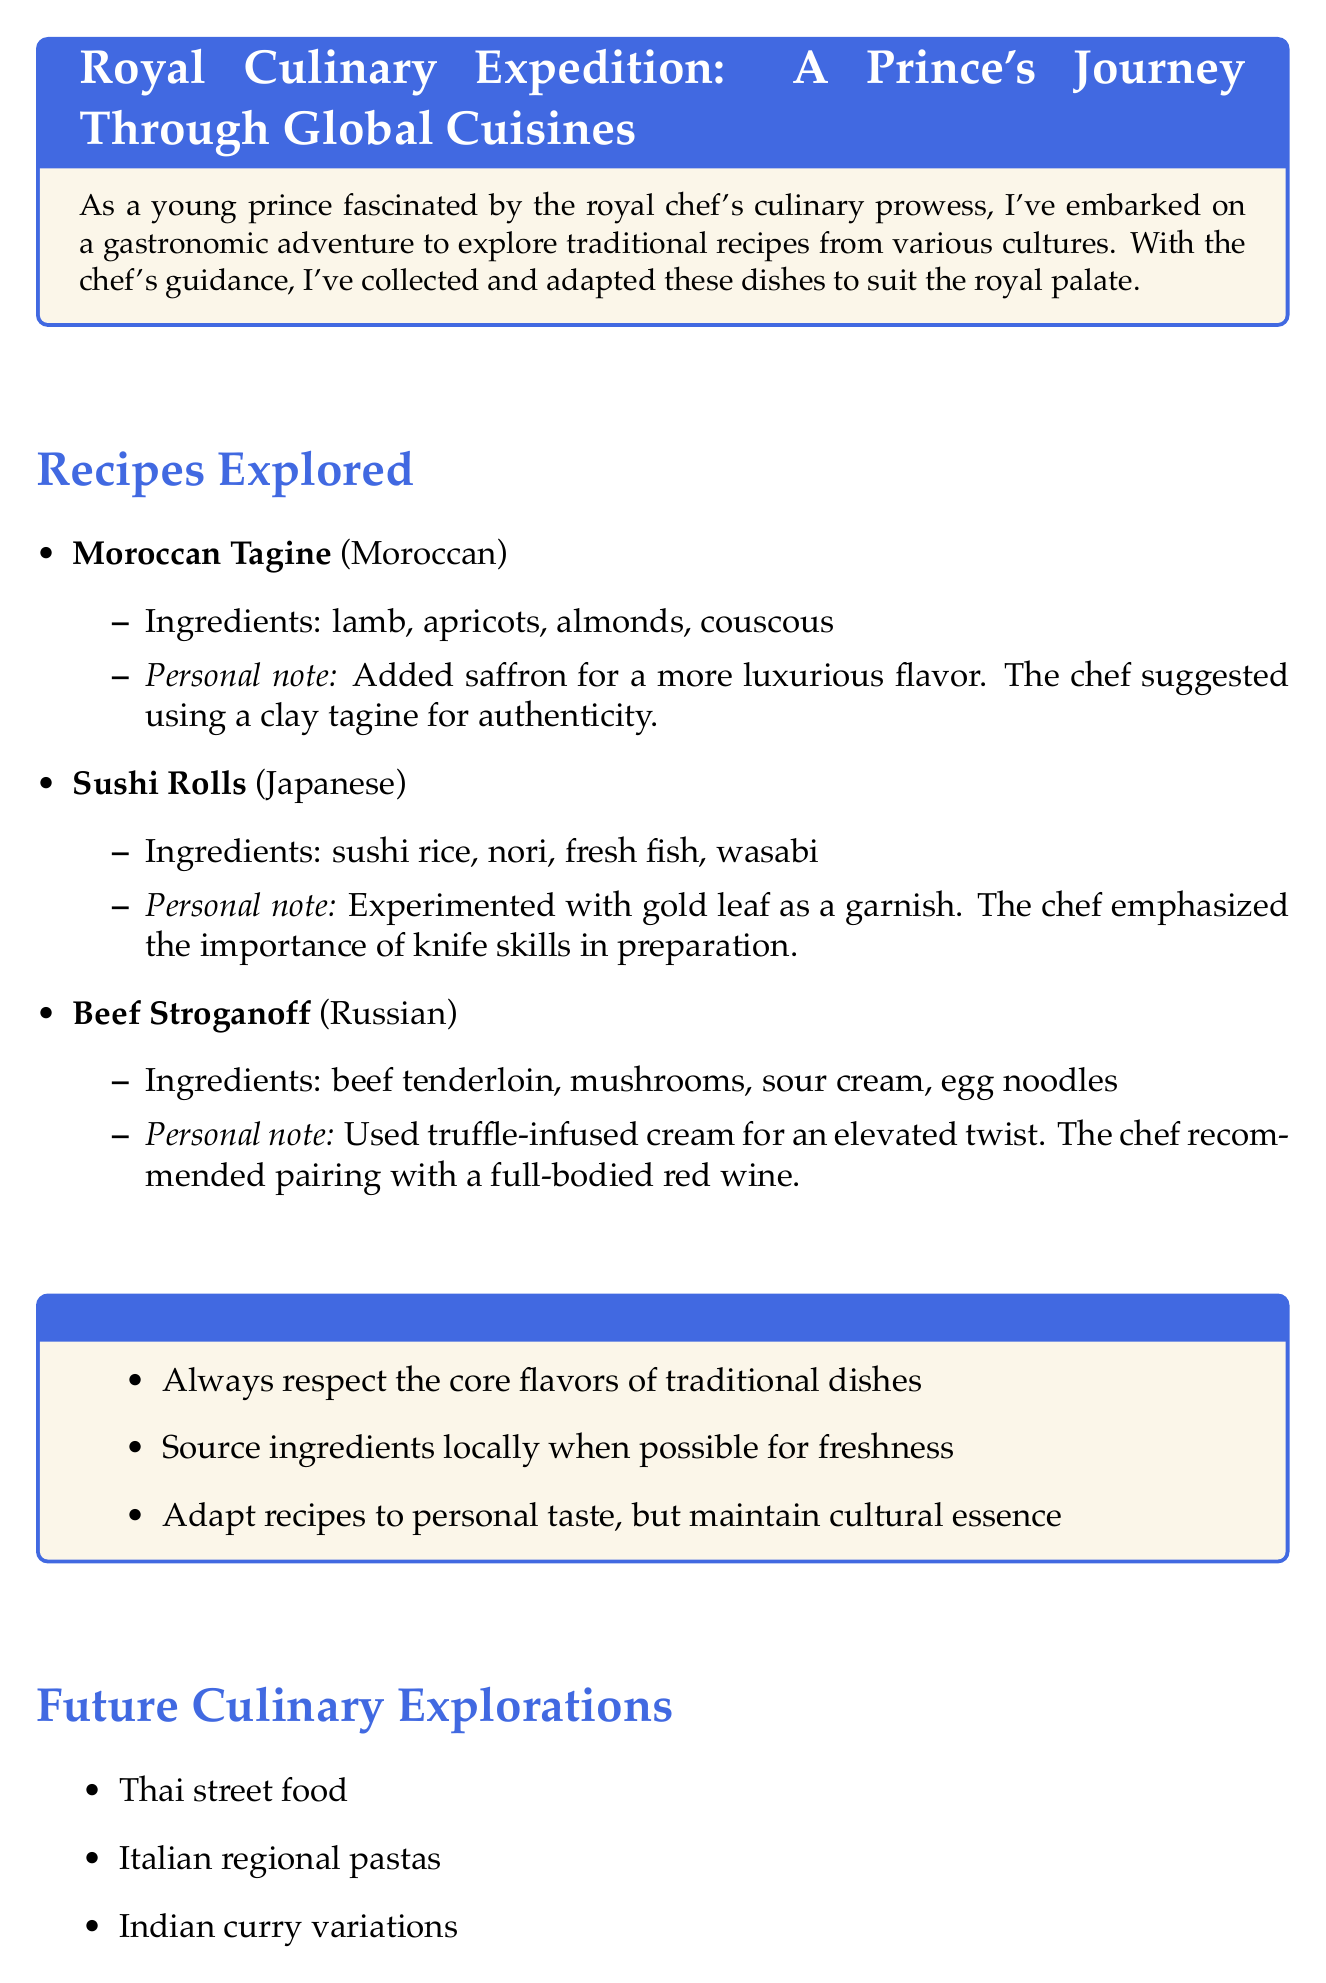What is the title of the document? The title is prominently stated at the beginning and reflects the content of the notes.
Answer: Royal Culinary Expedition: A Prince's Journey Through Global Cuisines How many recipes are explored in the document? The document lists a specific number of recipes in the section that details them.
Answer: 3 What ingredient is used in the Moroccan Tagine? The Moroccan Tagine recipe lists its ingredients, highlighting what is used.
Answer: lamb Which cuisine does Sushi Rolls belong to? The document specifies the cultural origin of each recipe, including Sushi Rolls.
Answer: Japanese What personal note is associated with Beef Stroganoff? Each recipe includes a personal note that describes a modification or suggestion.
Answer: Used truffle-infused cream for an elevated twist What is one of the future culinary explorations mentioned? The document outlines future areas of exploration, listing various cuisines.
Answer: Thai street food Who is the author of the notes? The introduction states the author’s title and context within the document.
Answer: a young prince What is emphasized by the chef regarding Sushi Rolls? The chef's wisdom section includes insights that relate to each recipe.
Answer: knife skills How does the chef recommend pairing Beef Stroganoff? The personal note for Beef Stroganoff indicates a suggested pairing.
Answer: full-bodied red wine 